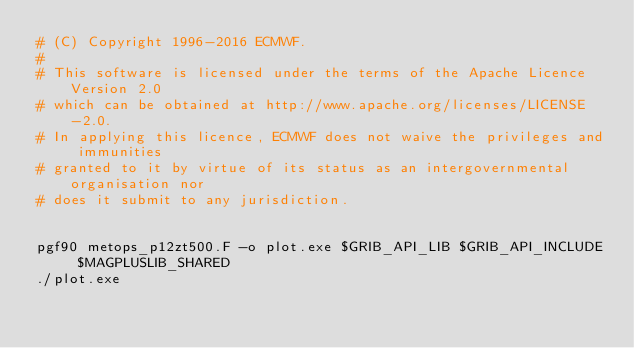Convert code to text. <code><loc_0><loc_0><loc_500><loc_500><_Bash_># (C) Copyright 1996-2016 ECMWF.
# 
# This software is licensed under the terms of the Apache Licence Version 2.0
# which can be obtained at http://www.apache.org/licenses/LICENSE-2.0. 
# In applying this licence, ECMWF does not waive the privileges and immunities 
# granted to it by virtue of its status as an intergovernmental organisation nor
# does it submit to any jurisdiction.


pgf90 metops_p12zt500.F -o plot.exe $GRIB_API_LIB $GRIB_API_INCLUDE $MAGPLUSLIB_SHARED
./plot.exe 
</code> 